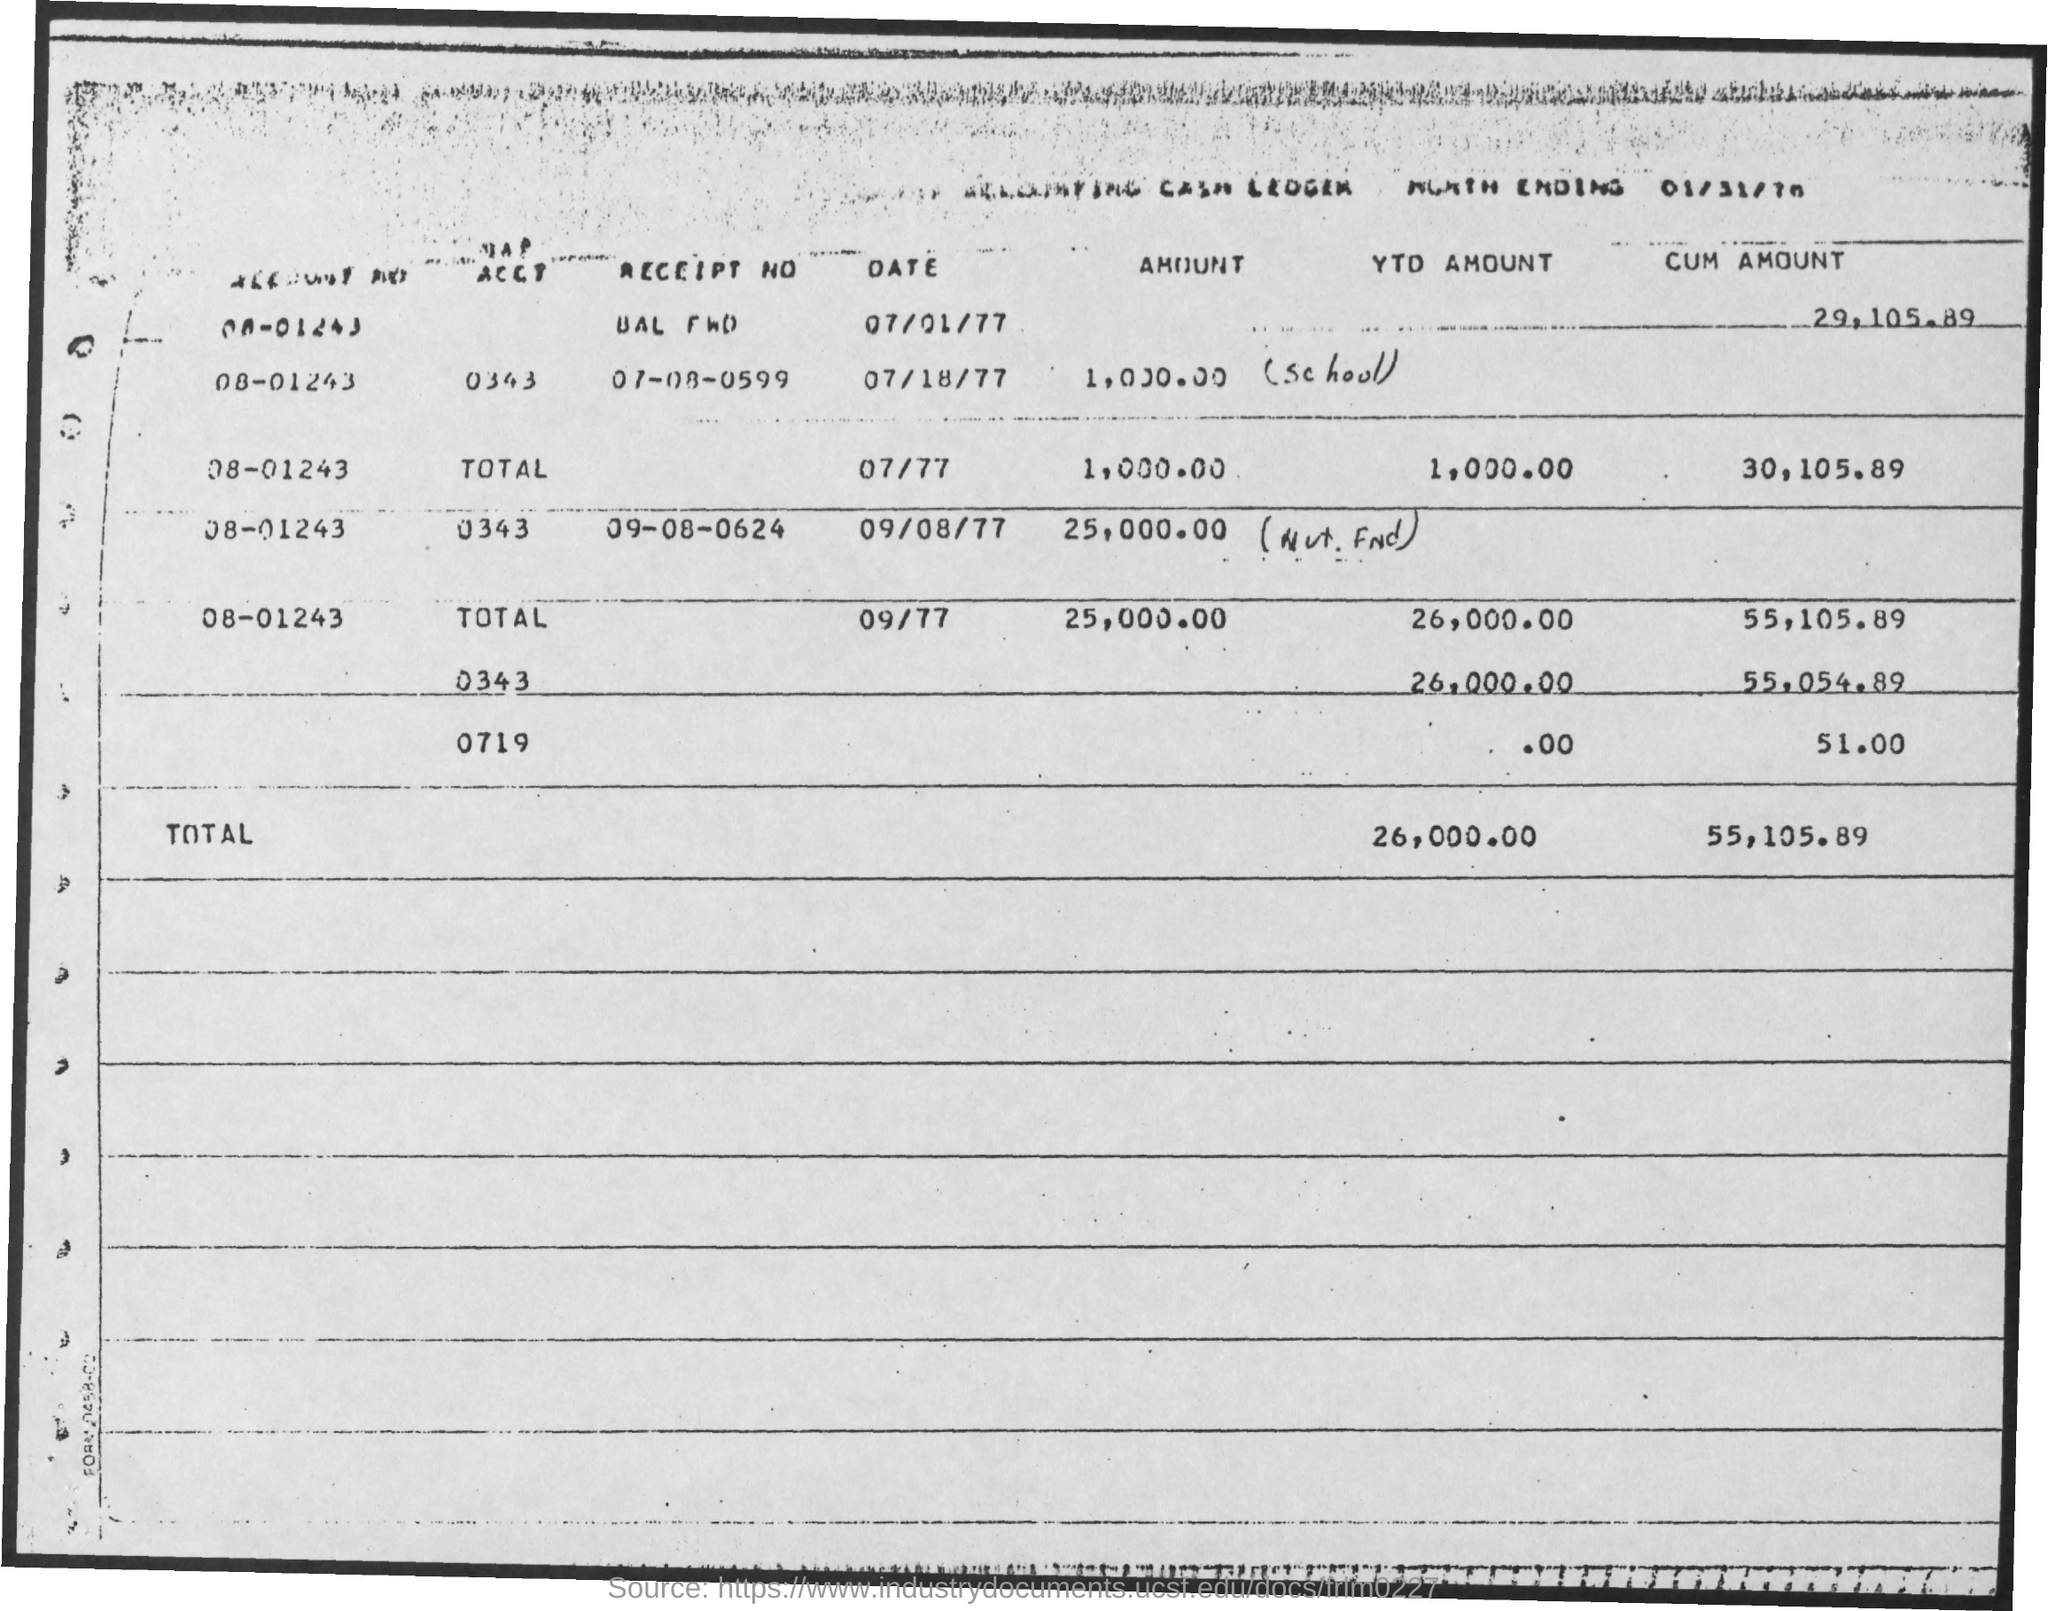What is the third account number listed in the table?
Provide a short and direct response. 08-01243. 